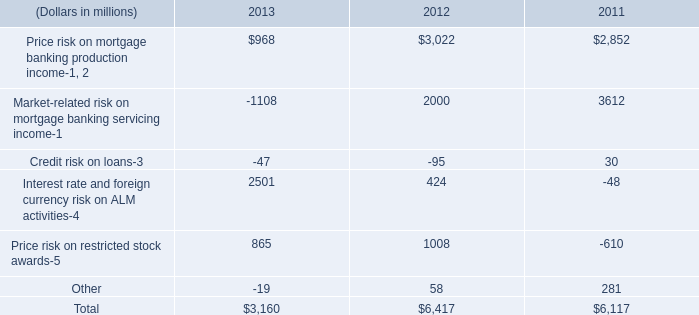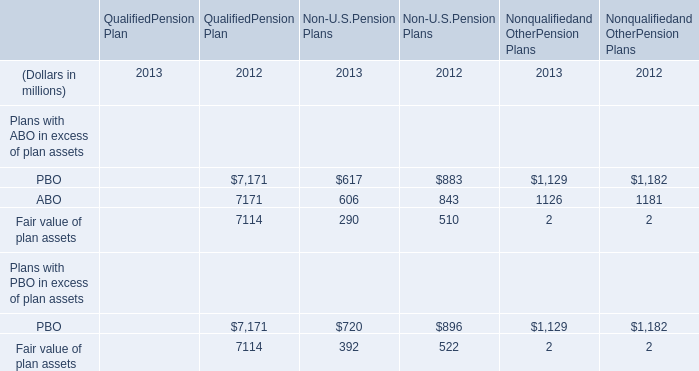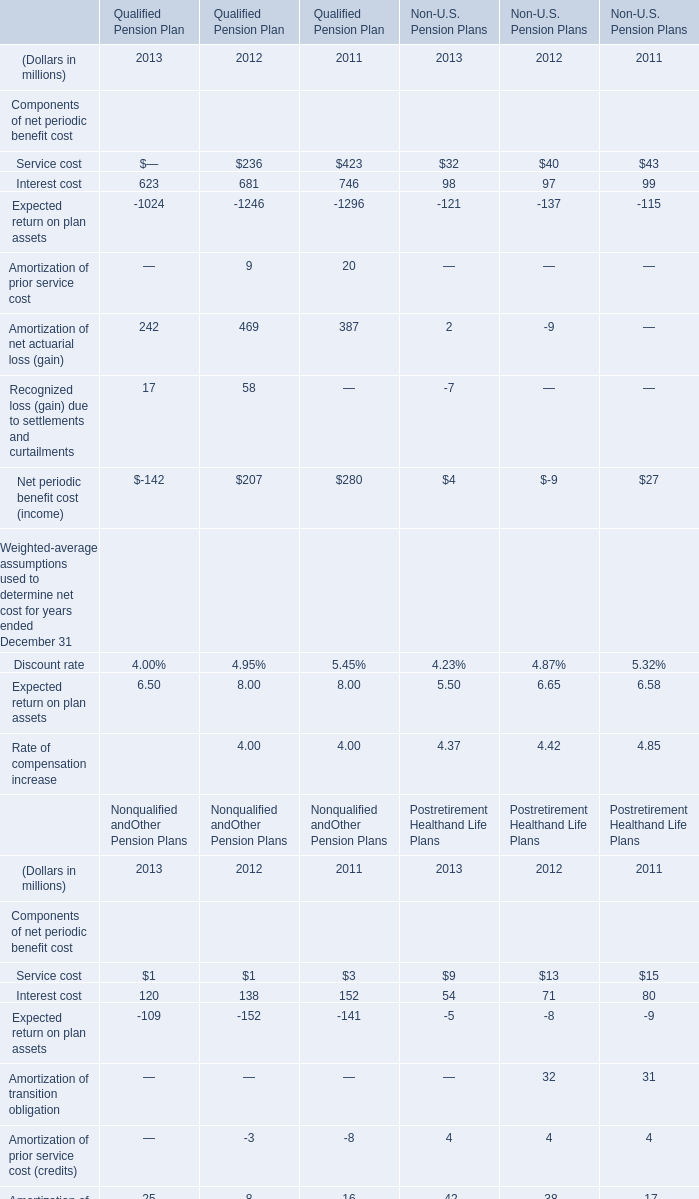What's the growth rate of Interest cost of Qualified Pension Plan in 2013? (in %) 
Computations: ((623 - 681) / 681)
Answer: -0.08517. 